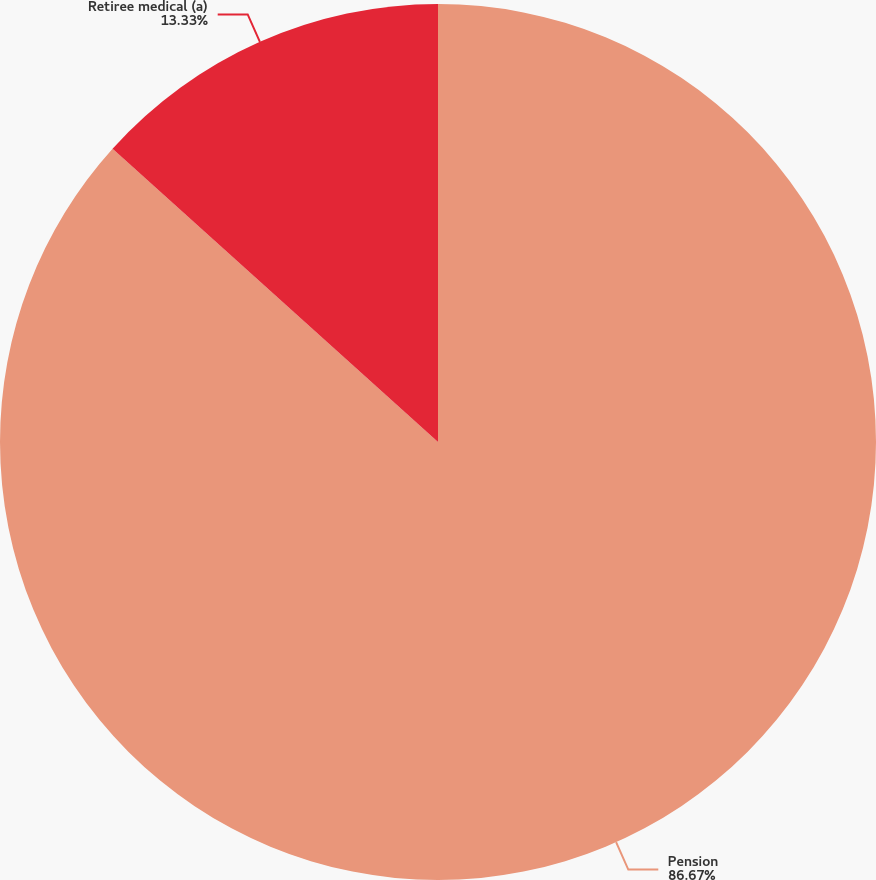Convert chart. <chart><loc_0><loc_0><loc_500><loc_500><pie_chart><fcel>Pension<fcel>Retiree medical (a)<nl><fcel>86.67%<fcel>13.33%<nl></chart> 